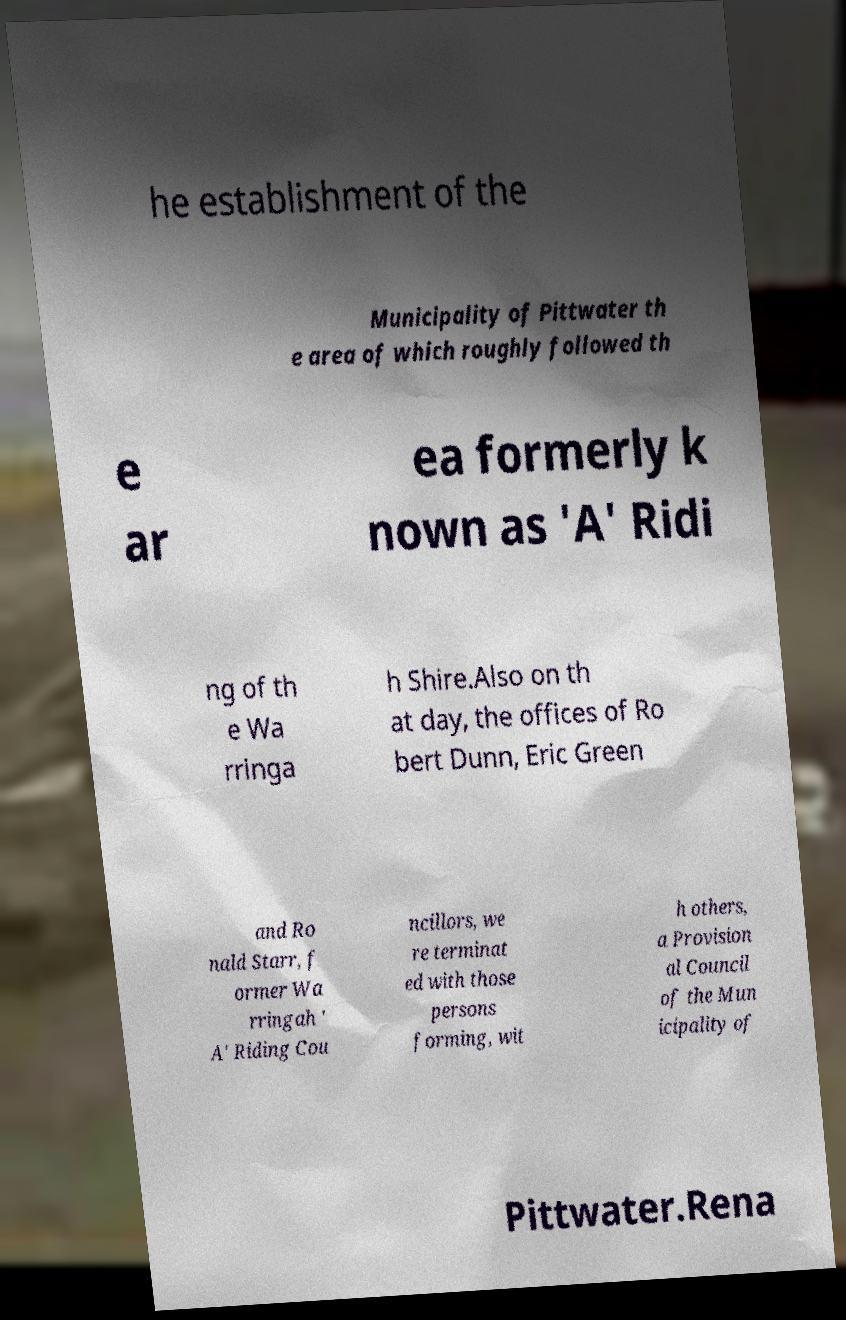Could you assist in decoding the text presented in this image and type it out clearly? he establishment of the Municipality of Pittwater th e area of which roughly followed th e ar ea formerly k nown as 'A' Ridi ng of th e Wa rringa h Shire.Also on th at day, the offices of Ro bert Dunn, Eric Green and Ro nald Starr, f ormer Wa rringah ' A' Riding Cou ncillors, we re terminat ed with those persons forming, wit h others, a Provision al Council of the Mun icipality of Pittwater.Rena 